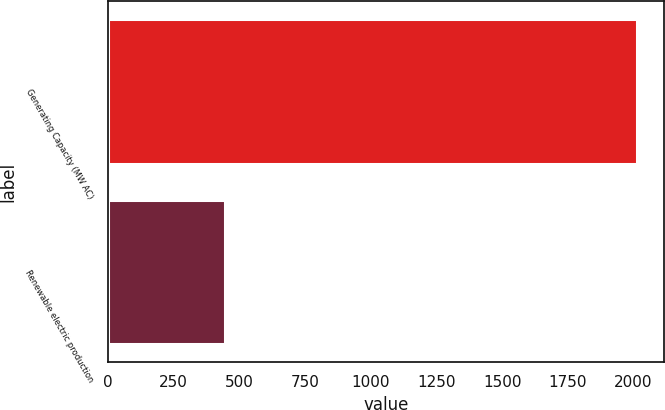Convert chart to OTSL. <chart><loc_0><loc_0><loc_500><loc_500><bar_chart><fcel>Generating Capacity (MW AC)<fcel>Renewable electric production<nl><fcel>2014<fcel>446<nl></chart> 